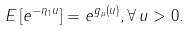<formula> <loc_0><loc_0><loc_500><loc_500>E \left [ e ^ { - \eta _ { 1 } u } \right ] = e ^ { g _ { \mu } ( u ) } , \forall \, u > 0 .</formula> 